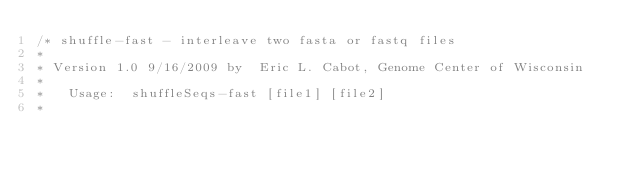<code> <loc_0><loc_0><loc_500><loc_500><_C_>/* shuffle-fast - interleave two fasta or fastq files 
*
* Version 1.0 9/16/2009 by  Eric L. Cabot, Genome Center of Wisconsin 
*
*   Usage:  shuffleSeqs-fast [file1] [file2]
*</code> 